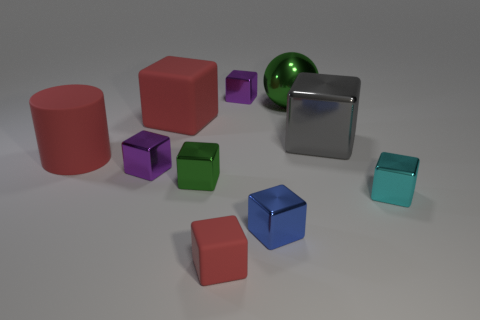How big is the red rubber cube that is behind the big gray metal cube?
Your response must be concise. Large. The big green metal object is what shape?
Offer a very short reply. Sphere. Do the purple object that is on the left side of the small red rubber object and the shiny block that is behind the big green metal ball have the same size?
Your answer should be very brief. Yes. How big is the purple metal cube to the left of the small metal cube that is behind the large green sphere that is on the left side of the big gray thing?
Keep it short and to the point. Small. The tiny matte thing right of the green object that is left of the small metallic block that is behind the big green metal thing is what shape?
Your response must be concise. Cube. What shape is the green metal object on the right side of the small blue object?
Make the answer very short. Sphere. Are the cylinder and the tiny blue object in front of the small cyan block made of the same material?
Your response must be concise. No. What number of other objects are the same shape as the cyan object?
Provide a short and direct response. 7. There is a large rubber cube; does it have the same color as the matte thing to the right of the green metallic block?
Your answer should be compact. Yes. The tiny purple metal thing that is on the left side of the small purple cube that is on the right side of the small rubber block is what shape?
Give a very brief answer. Cube. 